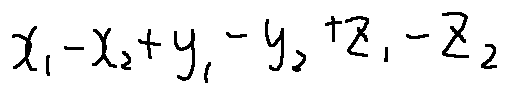<formula> <loc_0><loc_0><loc_500><loc_500>x _ { 1 } - x _ { 2 } + y _ { 1 } - y _ { 2 } + z _ { 1 } - z _ { 2 }</formula> 